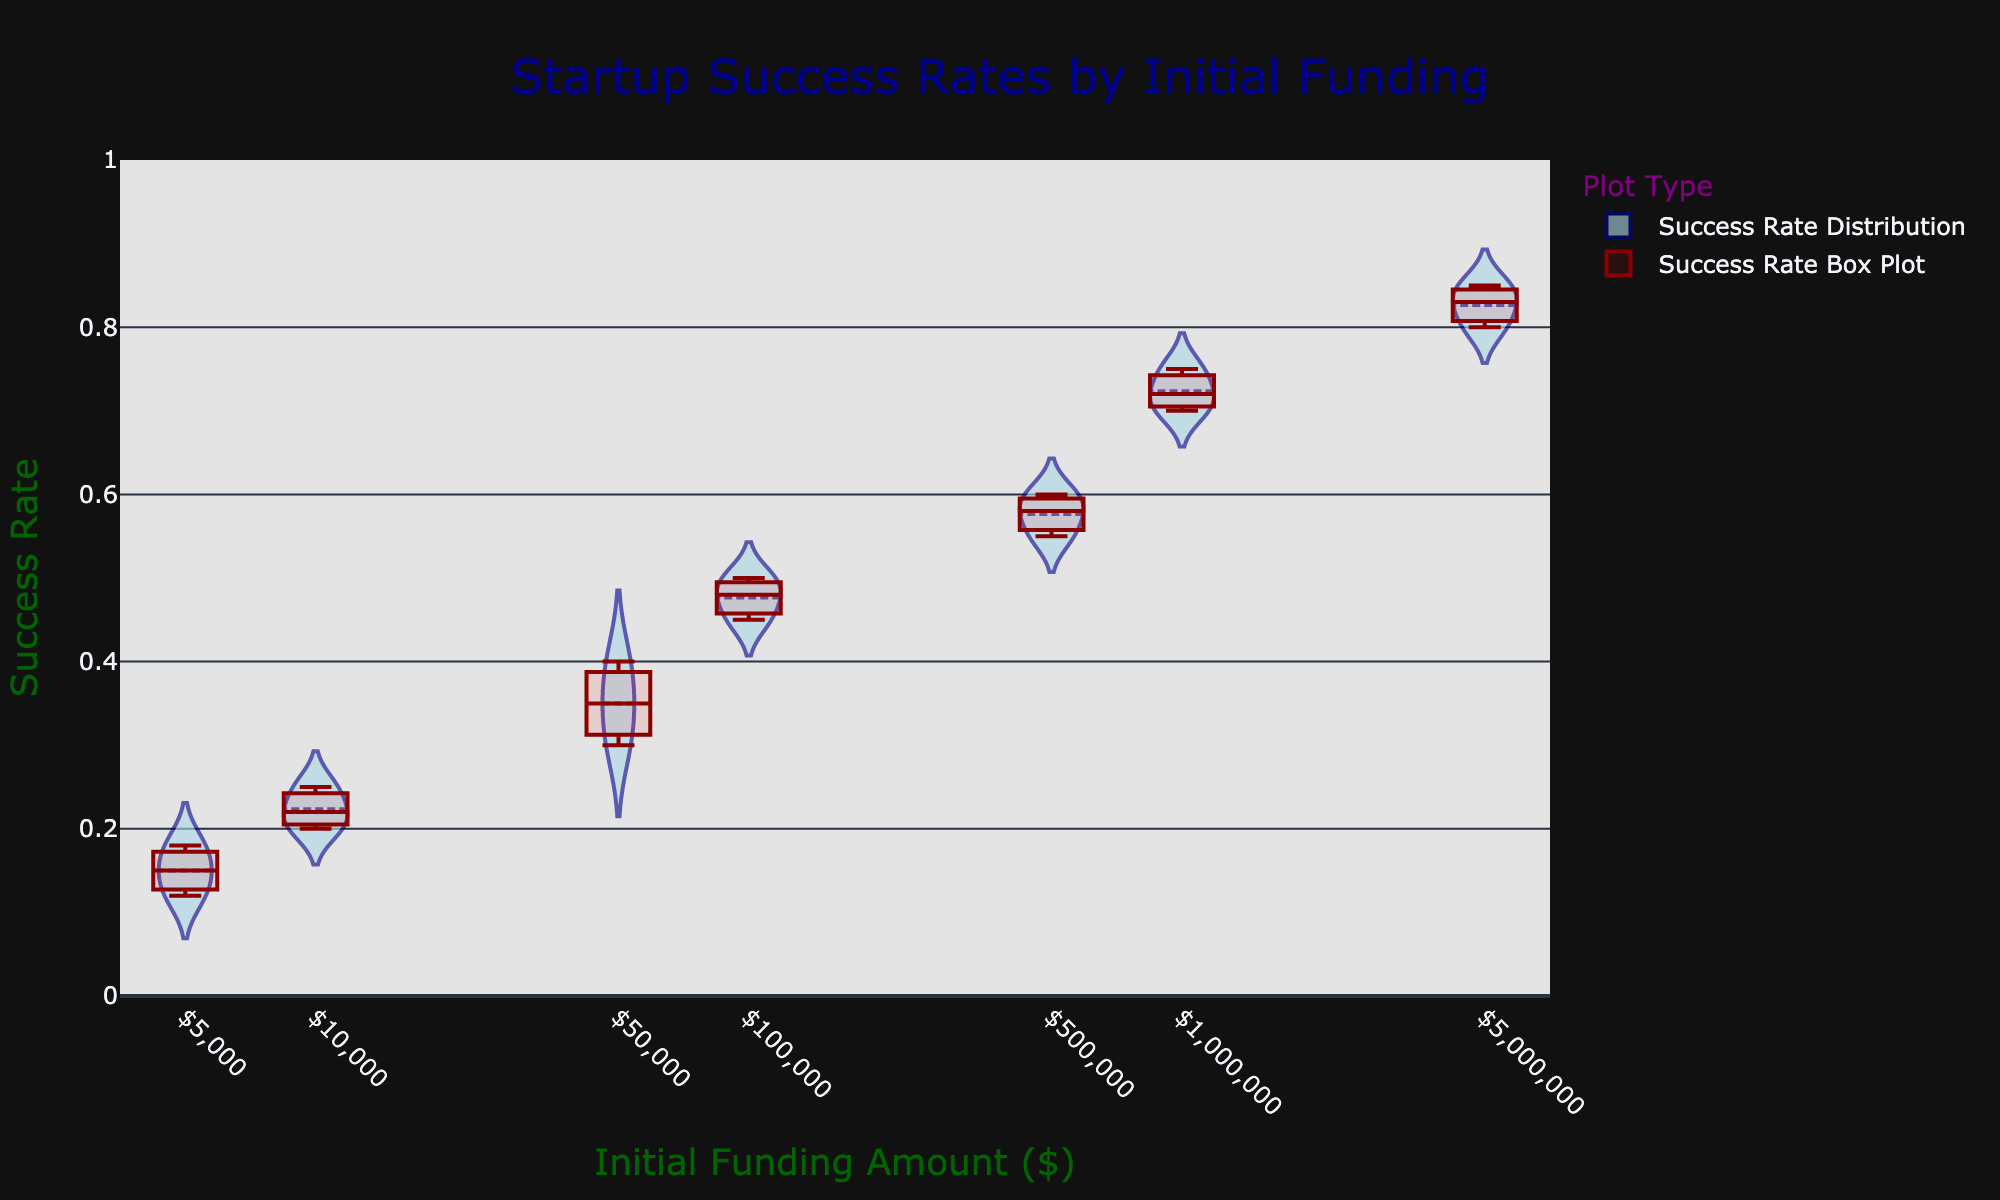What's the title of the chart? The title of the chart appears at the top center and reads "Startup Success Rates by Initial Funding".
Answer: Startup Success Rates by Initial Funding What are the x-axis and y-axis titles? The x-axis title is "Initial Funding Amount ($)" and the y-axis title is "Success Rate". Their descriptions are derived from the axis labels displayed below and to the left of the chart, respectively.
Answer: Initial Funding Amount ($); Success Rate What's the range of the y-axis? The y-axis range is visually set from 0 to 1, as indicated by the values along the vertical axis.
Answer: 0 to 1 Which initial funding amount has the highest median success rate? To determine the highest median, look at the median line in the overlayed box plot within each funding category. The categories with higher funding amounts, especially $5,000,000, show higher median values.
Answer: $5,000,000 How does the success rate distribution vary with increased funding amounts? The success rate distributions widen and shift upward as the initial funding amounts increase. The violins become broader, showing more varied success probabilities, and collectively higher success rates.
Answer: Wider and higher with increased funding What is the overall pattern in the success rates as the initial funding amount increases from $5,000 to $5,000,000? There is a clear upward trend in success rates from lower funding amounts to higher ones. The violins and box plots indicate a significant positive correlation between initial funding and success rates.
Answer: Upward trend Is there any overlap in success rates between initial funding amounts of $50,000 and $100,000? By examining the shapes of the violin plots and the box plots, there's a notable overlap between the success rates for these two funding amounts. Both distributions range from about 0.3 to 0.5.
Answer: Yes Which initial funding amount shows the most variability in success rates? Variability is indicated by the width and spread of the violin plot. The violins for higher funding amounts, like $5,000,000, show the widest distributions, reflecting higher variability.
Answer: $5,000,000 Between which funding amounts is there the most abrupt increase in median success rates? Comparing the median lines in the box plots, there is a notable jump in median success rates between $50,000 and $100,000, indicating a steep increase.
Answer: $50,000 and $100,000 